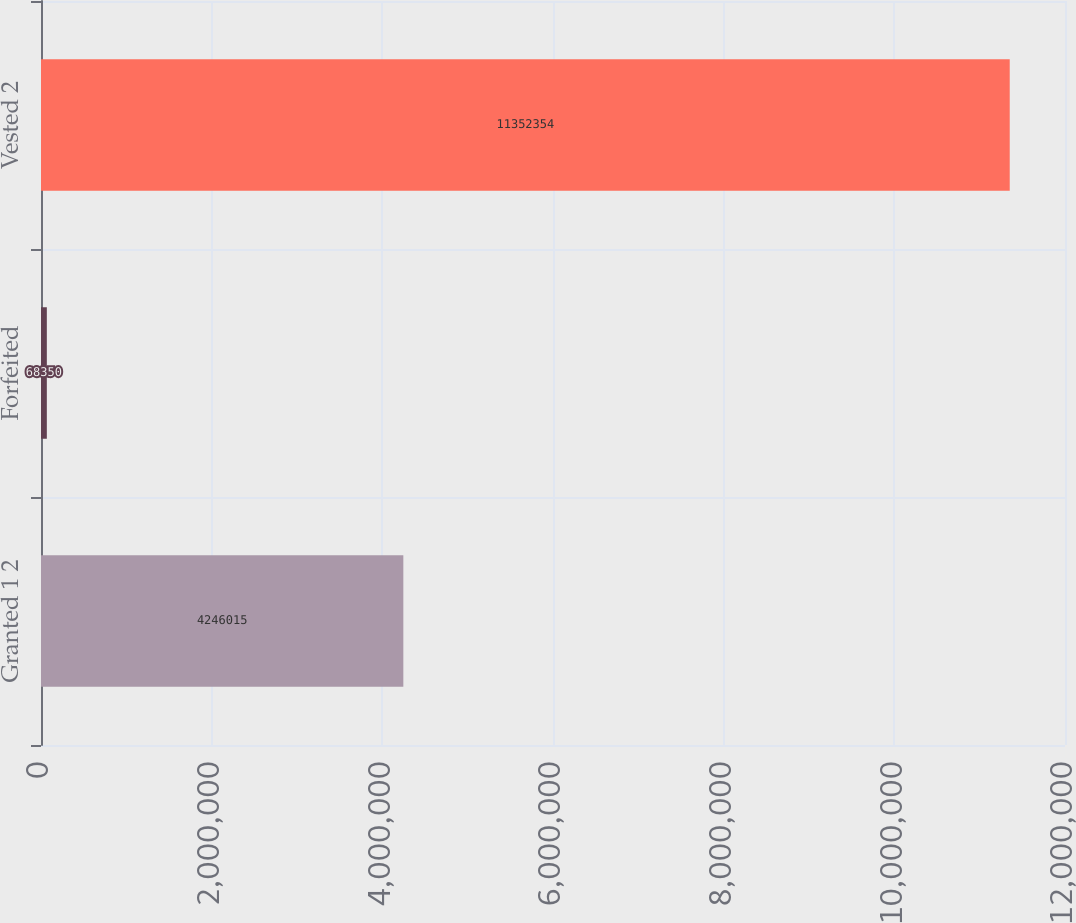Convert chart. <chart><loc_0><loc_0><loc_500><loc_500><bar_chart><fcel>Granted 1 2<fcel>Forfeited<fcel>Vested 2<nl><fcel>4.24602e+06<fcel>68350<fcel>1.13524e+07<nl></chart> 